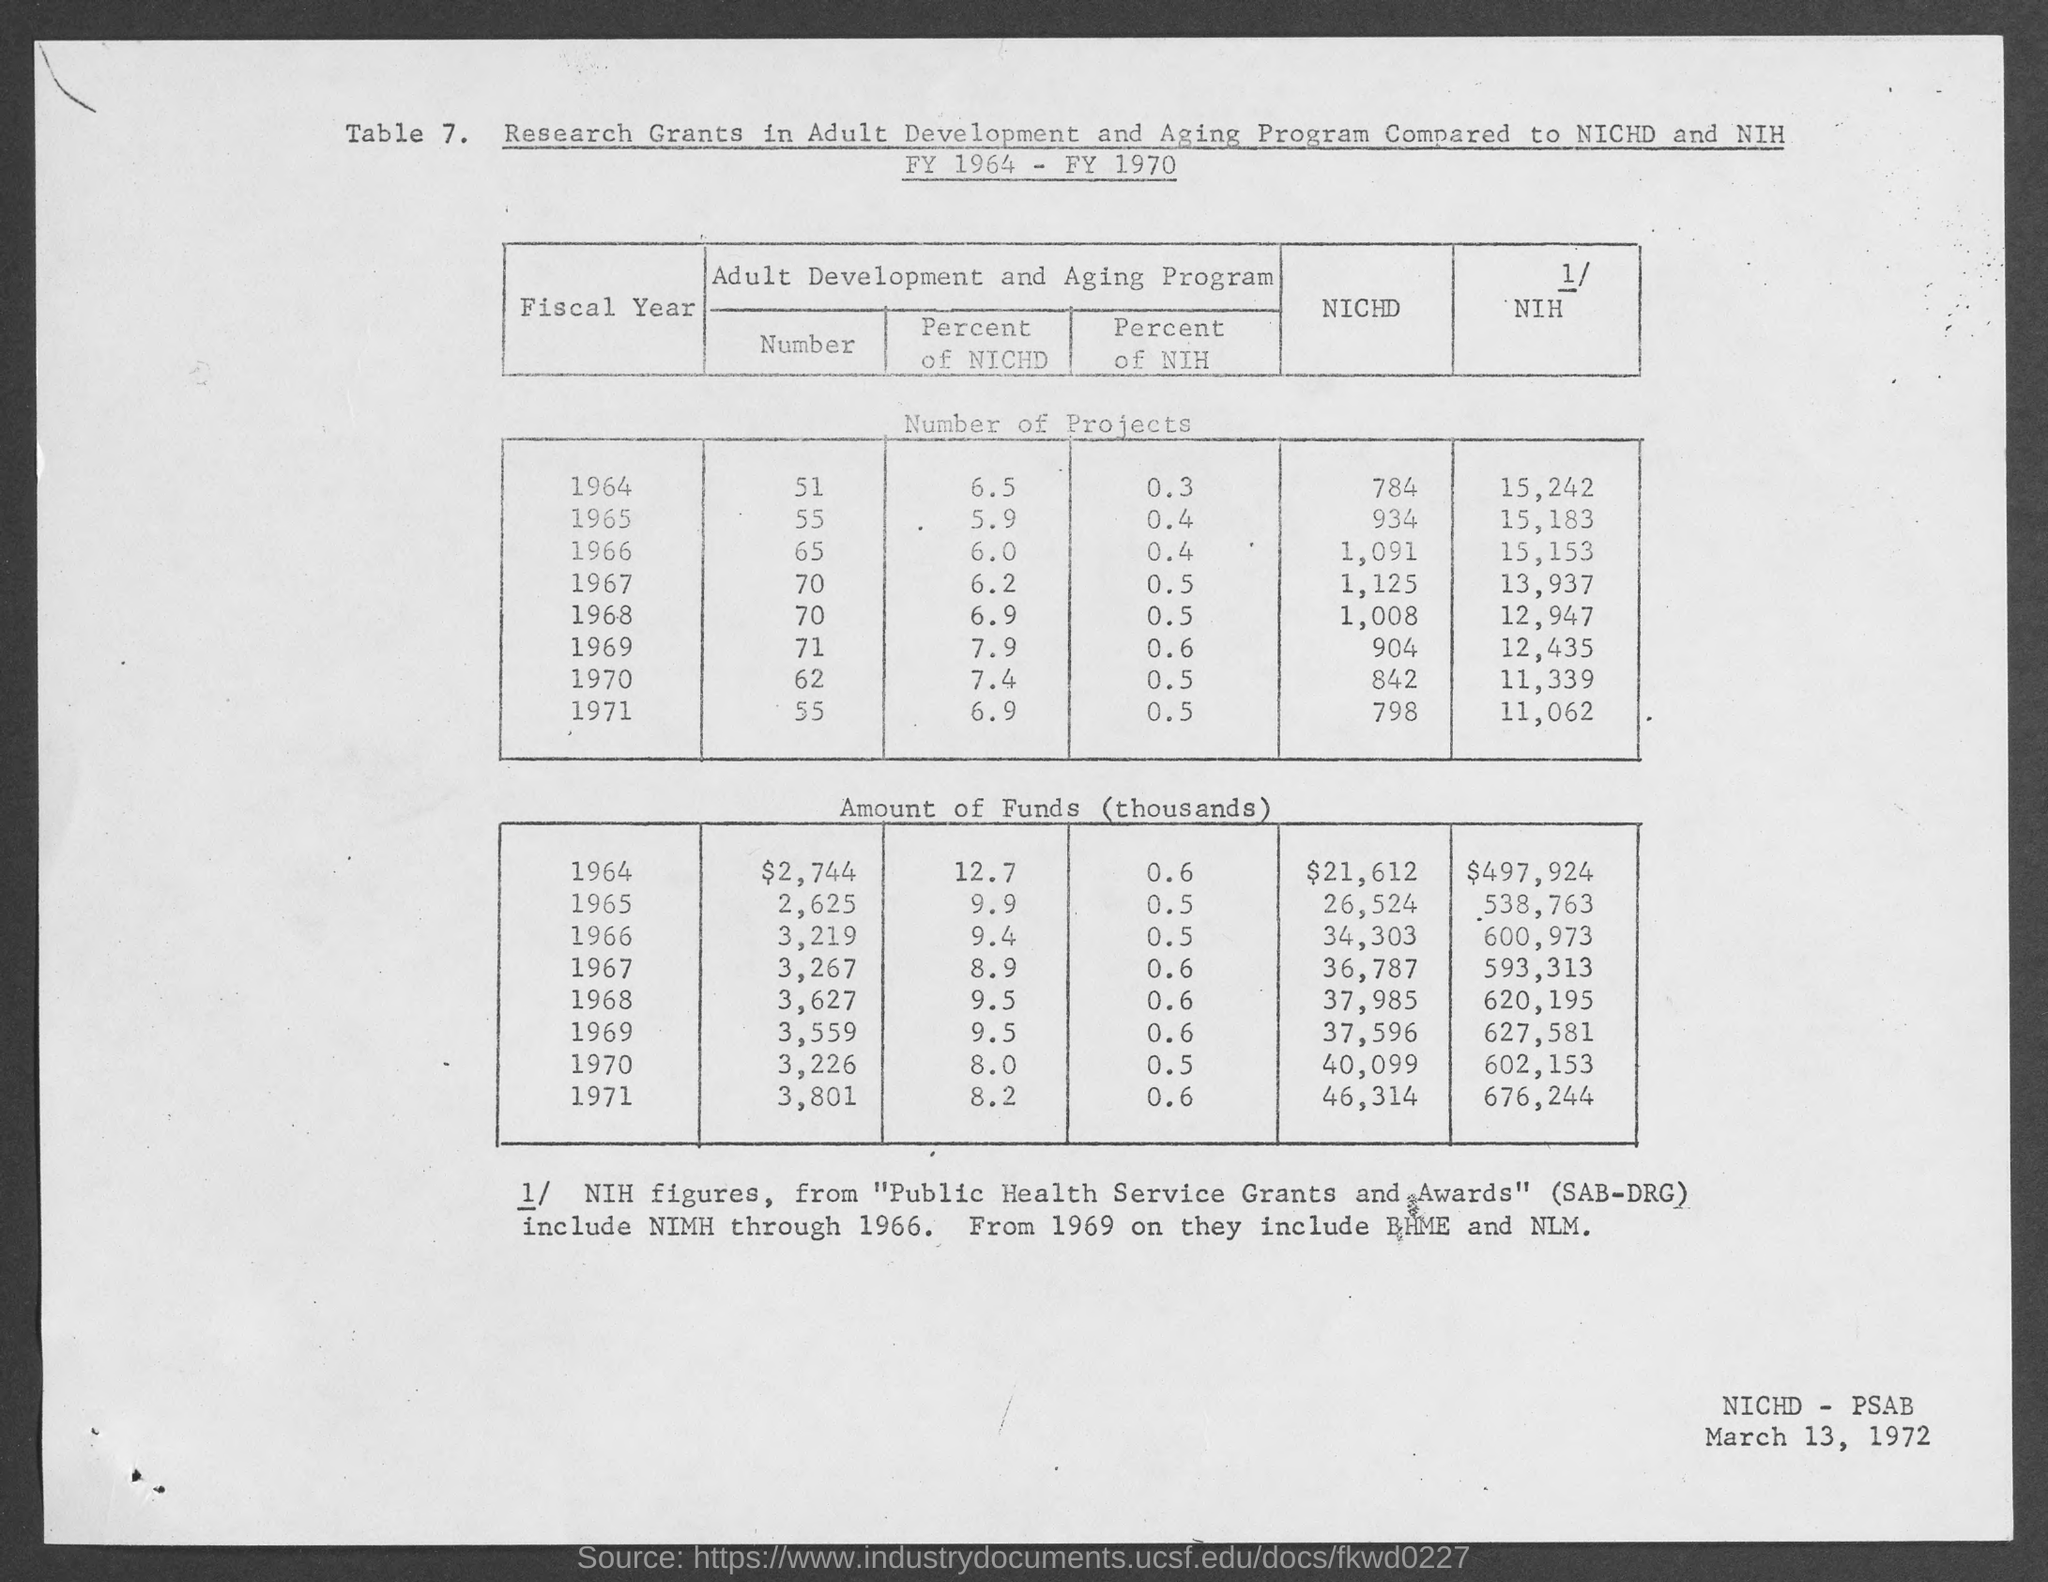Highlight a few significant elements in this photo. The date at the bottom-right corner of the page is March 13, 1972. The table number is 7. 